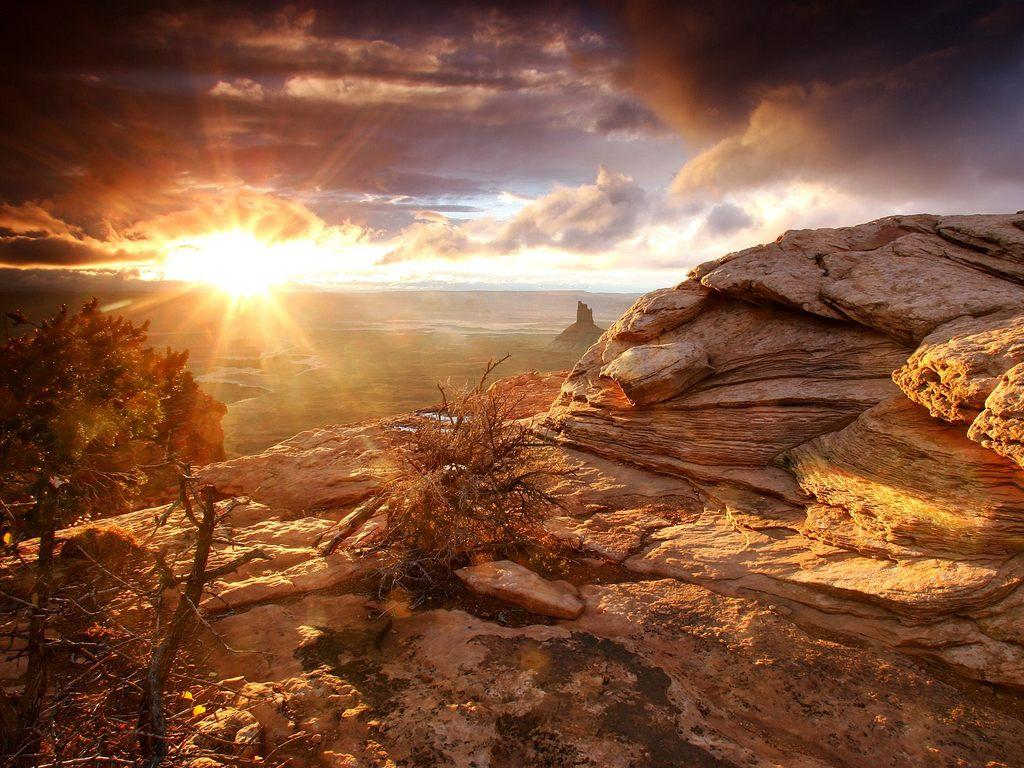What is located on the right side of the image? There is a rock on the right side of the image. What type of vegetation can be seen in the image? There are trees in the image. What is visible in the background of the image? The sun and the sky are visible in the background of the image. Can you see a swing in the image? No, there is no swing present in the image. Is there a cart visible in the image? No, there is no cart present in the image. 